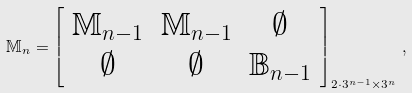<formula> <loc_0><loc_0><loc_500><loc_500>\mathbb { M } _ { n } = \left [ \begin{array} { c c c } \mathbb { M } _ { n - 1 } & \mathbb { M } _ { n - 1 } & \emptyset \\ \emptyset & \emptyset & \mathbb { B } _ { n - 1 } \end{array} \right ] _ { 2 \cdot 3 ^ { n - 1 } \times 3 ^ { n } } \, ,</formula> 